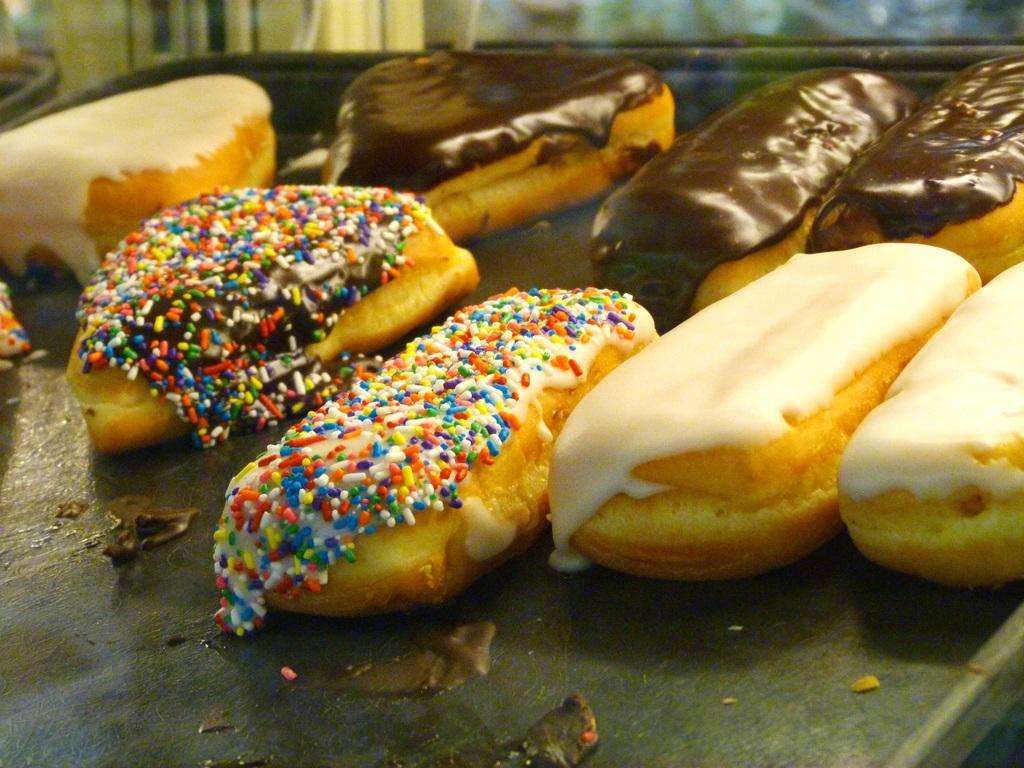Could you give a brief overview of what you see in this image? In the center of the image a table is there. On table cakes are present. 